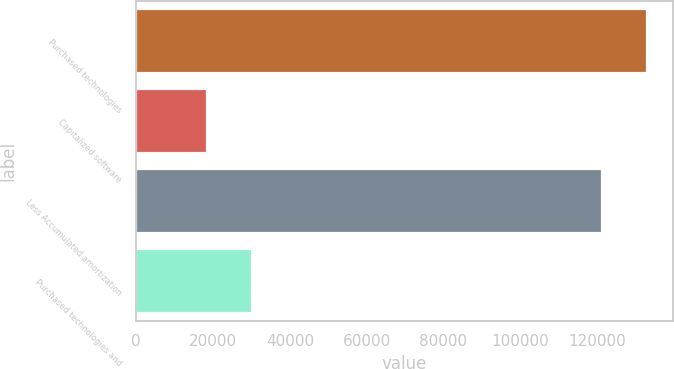Convert chart. <chart><loc_0><loc_0><loc_500><loc_500><bar_chart><fcel>Purchased technologies<fcel>Capitalized software<fcel>Less Accumulated amortization<fcel>Purchased technologies and<nl><fcel>133029<fcel>18444<fcel>121348<fcel>30125<nl></chart> 